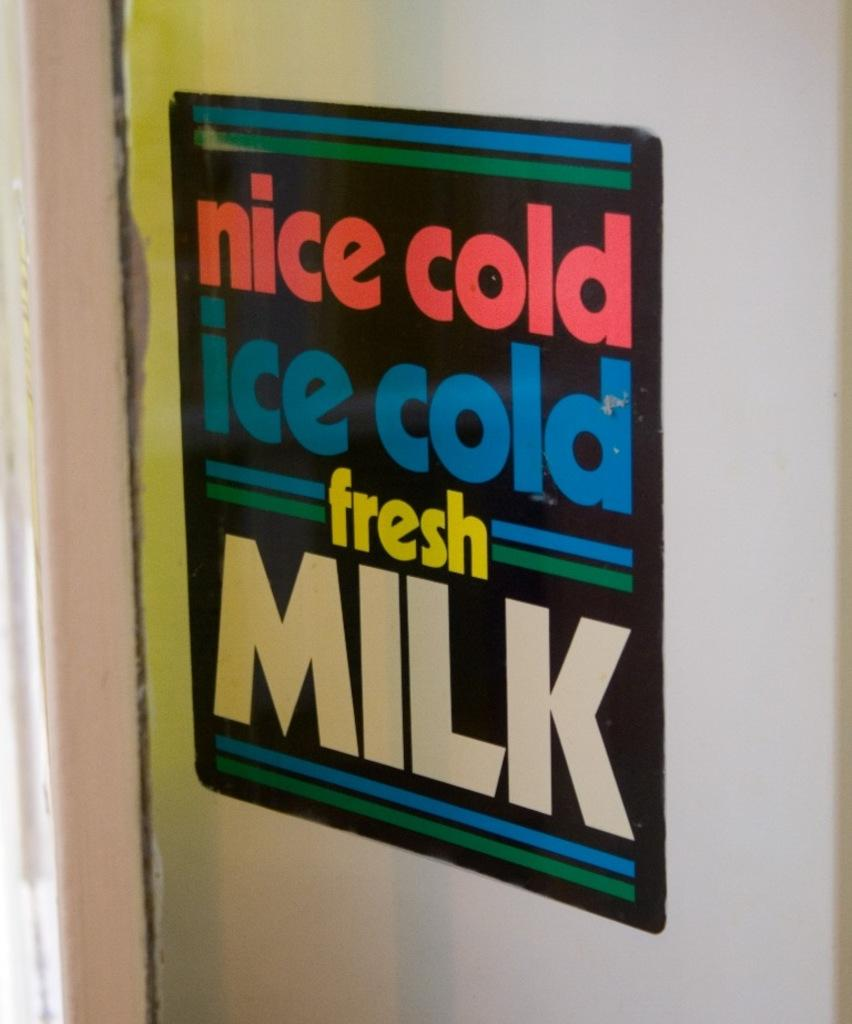Provide a one-sentence caption for the provided image. Ice cold ice cold fresh milk sign on a door. 